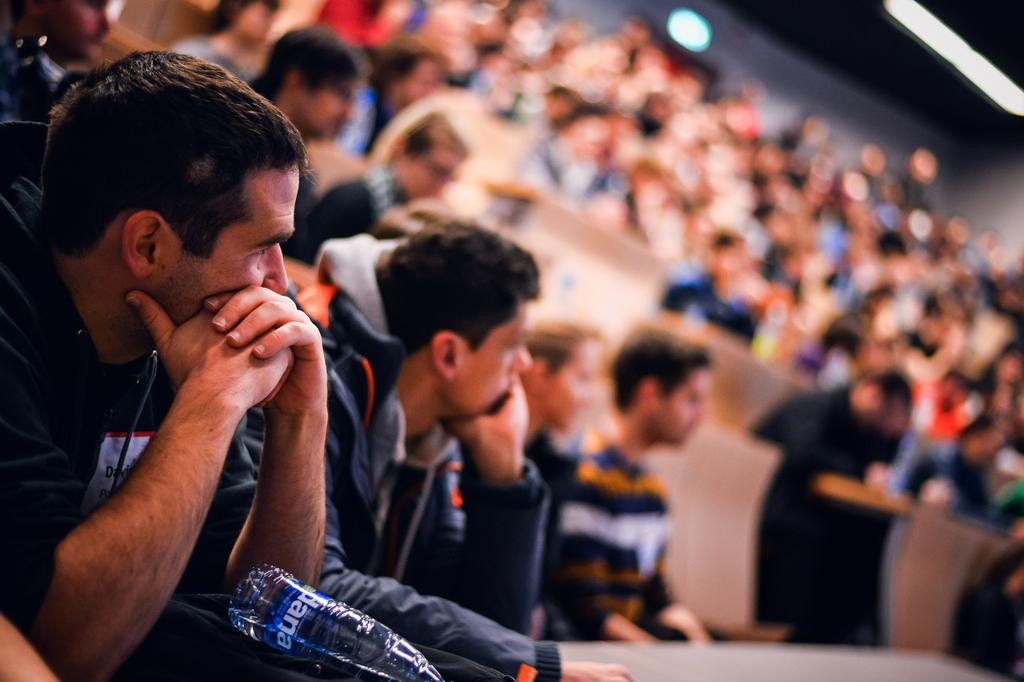What is happening in the foreground of the image? There are people sitting in the foreground of the image, and there is a bottle present as well. Can you describe the background of the image? The background of the image is blurry. How much money is being exchanged between the people in the image? There is no indication of money or any exchange happening in the image. What happens to the bottle when it bursts in the image? There is no bottle bursting in the image. 